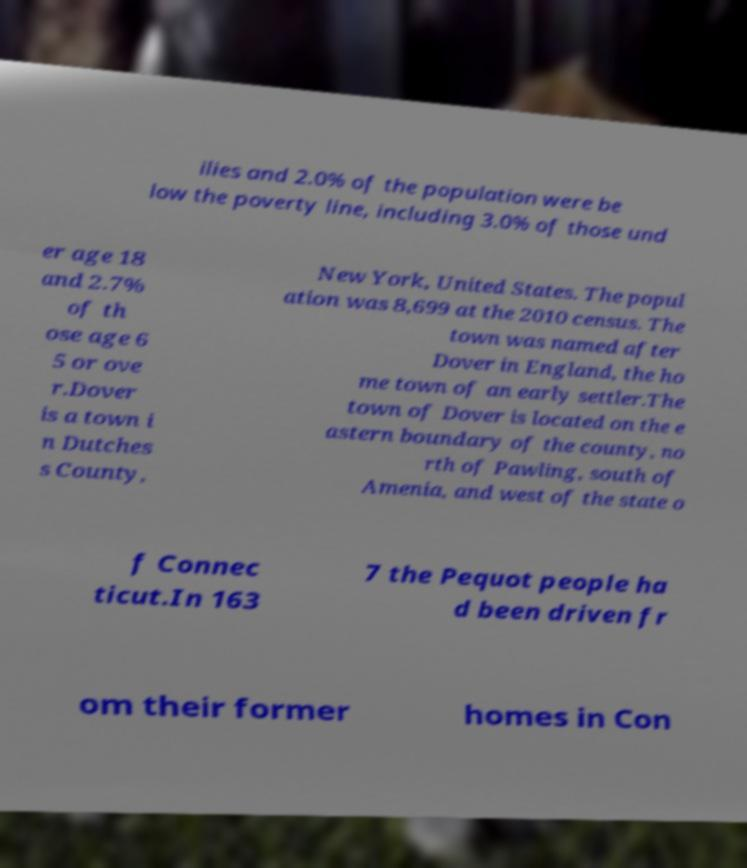Can you read and provide the text displayed in the image?This photo seems to have some interesting text. Can you extract and type it out for me? ilies and 2.0% of the population were be low the poverty line, including 3.0% of those und er age 18 and 2.7% of th ose age 6 5 or ove r.Dover is a town i n Dutches s County, New York, United States. The popul ation was 8,699 at the 2010 census. The town was named after Dover in England, the ho me town of an early settler.The town of Dover is located on the e astern boundary of the county, no rth of Pawling, south of Amenia, and west of the state o f Connec ticut.In 163 7 the Pequot people ha d been driven fr om their former homes in Con 